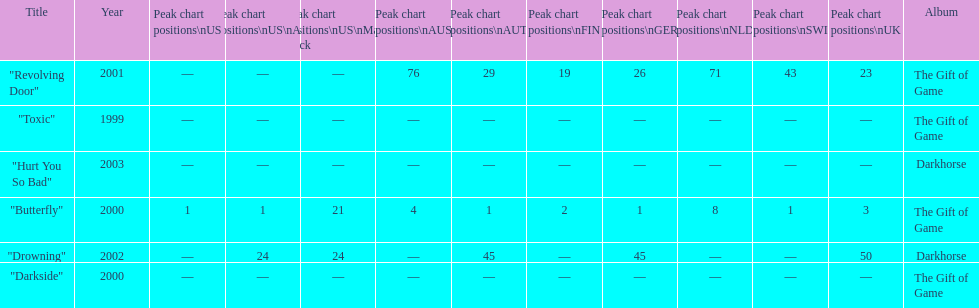How many singles have a ranking of 1 under ger? 1. Would you mind parsing the complete table? {'header': ['Title', 'Year', 'Peak chart positions\\nUS', 'Peak chart positions\\nUS\\nAlt.', 'Peak chart positions\\nUS\\nMain. Rock', 'Peak chart positions\\nAUS', 'Peak chart positions\\nAUT', 'Peak chart positions\\nFIN', 'Peak chart positions\\nGER', 'Peak chart positions\\nNLD', 'Peak chart positions\\nSWI', 'Peak chart positions\\nUK', 'Album'], 'rows': [['"Revolving Door"', '2001', '—', '—', '—', '76', '29', '19', '26', '71', '43', '23', 'The Gift of Game'], ['"Toxic"', '1999', '—', '—', '—', '—', '—', '—', '—', '—', '—', '—', 'The Gift of Game'], ['"Hurt You So Bad"', '2003', '—', '—', '—', '—', '—', '—', '—', '—', '—', '—', 'Darkhorse'], ['"Butterfly"', '2000', '1', '1', '21', '4', '1', '2', '1', '8', '1', '3', 'The Gift of Game'], ['"Drowning"', '2002', '—', '24', '24', '—', '45', '—', '45', '—', '—', '50', 'Darkhorse'], ['"Darkside"', '2000', '—', '—', '—', '—', '—', '—', '—', '—', '—', '—', 'The Gift of Game']]} 